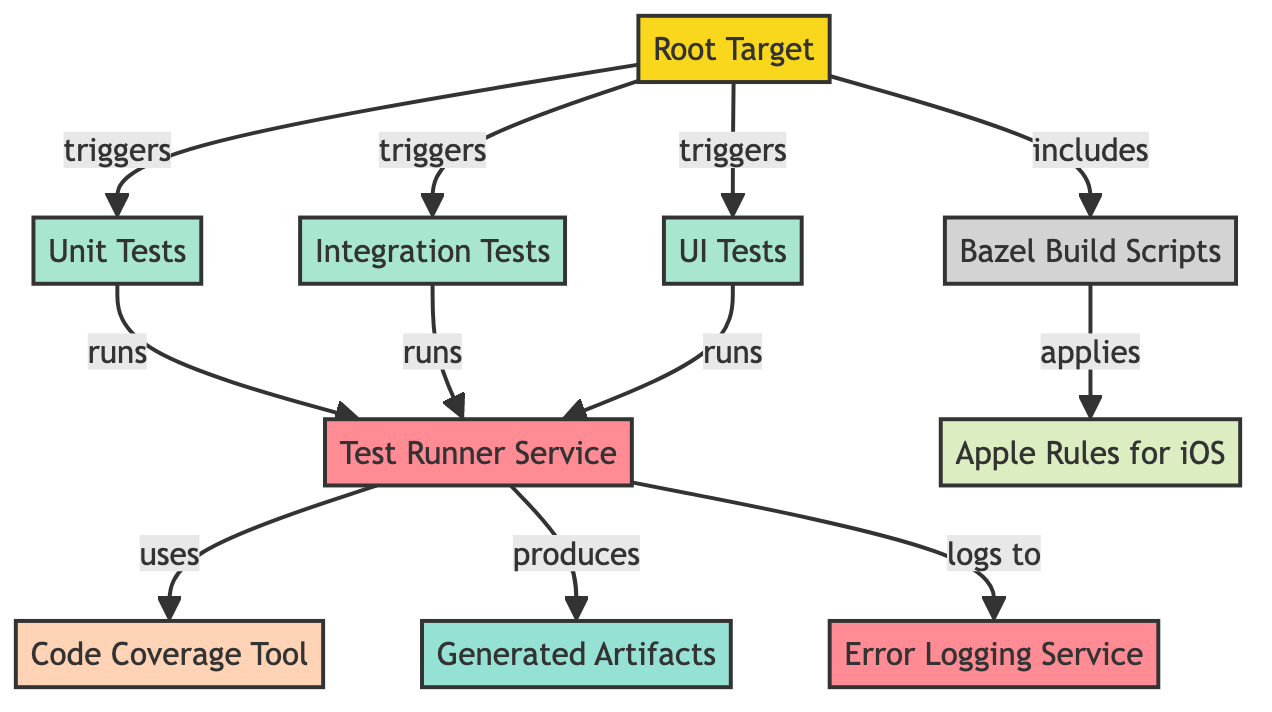What is the total number of nodes in the graph? The graph displays a total of ten nodes, each representing different elements such as targets, tests, services, and tools.
Answer: 10 Which node is the source in the diagram? In the directed graph, the "Root Target" node is identified as the source, which initiates the test triggering process.
Answer: Root Target How many types of tests are mentioned in the diagram? There are three types of tests indicated: Unit Tests, Integration Tests, and UI Tests, as represented by their respective nodes.
Answer: 3 What service does the "Test Runner Service" produce? The "Test Runner Service" produces "Generated Artifacts," as shown by the directed edge indicating this production relationship.
Answer: Generated Artifacts Which tool does the "Test Runner Service" use? The "Test Runner Service" uses the "Code Coverage Tool," as indicated by the edge labeled "uses" leading to that tool.
Answer: Code Coverage Tool What is the relationship between "Bazel Build Scripts" and "Apple Rules for iOS"? The relationship shows that "Bazel Build Scripts" applies "Apple Rules for iOS," indicating a usage or implementation dependency between these two components.
Answer: applies How many services are represented in the diagram? The diagram includes two services: "Test Runner Service" and "Error Logging Service," both depicted as separate nodes.
Answer: 2 What is logged to by the "Test Runner Service"? The "Test Runner Service" logs to the "Error Logging Service," as denoted by the directed edge labeled "logs to."
Answer: Error Logging Service Which node triggers the "UI Tests"? The "Root Target" node triggers the "UI Tests," as evidenced by the directed edge from the source node to the test node labeled "triggers."
Answer: Root Target 